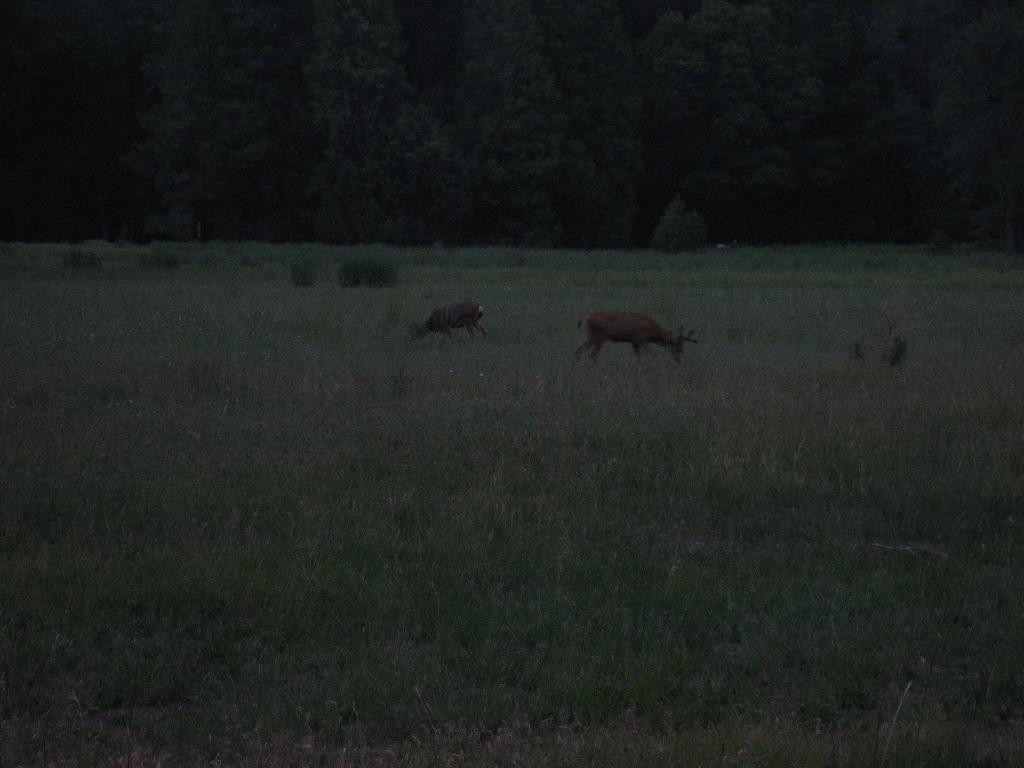In one or two sentences, can you explain what this image depicts? In this image there are deers grazing in a field, in the background there are trees. 